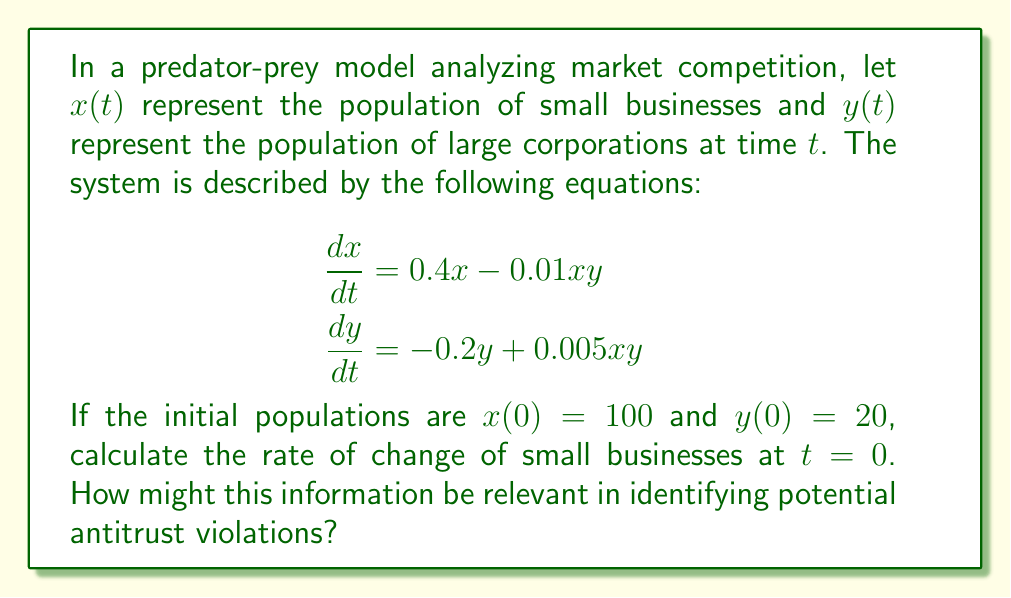Could you help me with this problem? To solve this problem, we'll follow these steps:

1) We're given the differential equation for $x(t)$:
   $$\frac{dx}{dt} = 0.4x - 0.01xy$$

2) We need to evaluate this at $t=0$, so we'll substitute the initial values:
   $x(0) = 100$ and $y(0) = 20$

3) Let's substitute these values into the equation:
   $$\frac{dx}{dt}\bigg|_{t=0} = 0.4(100) - 0.01(100)(20)$$

4) Now we can calculate:
   $$\frac{dx}{dt}\bigg|_{t=0} = 40 - 20 = 20$$

5) Interpretation: At $t=0$, the population of small businesses is increasing at a rate of 20 units per time period.

This information could be relevant for identifying potential antitrust violations because:

a) A positive growth rate for small businesses suggests a healthy competitive environment initially.

b) However, the presence of large corporations (y) in the model reduces the growth rate of small businesses, which could indicate potential market dominance.

c) By analyzing how this rate changes over time, we could identify if large corporations are suppressing the growth of small businesses, which might be an indicator of anti-competitive practices.

d) If the rate becomes negative over time, it might suggest that large corporations are driving small businesses out of the market, which could be a red flag for antitrust violations.
Answer: 20 units per time period 